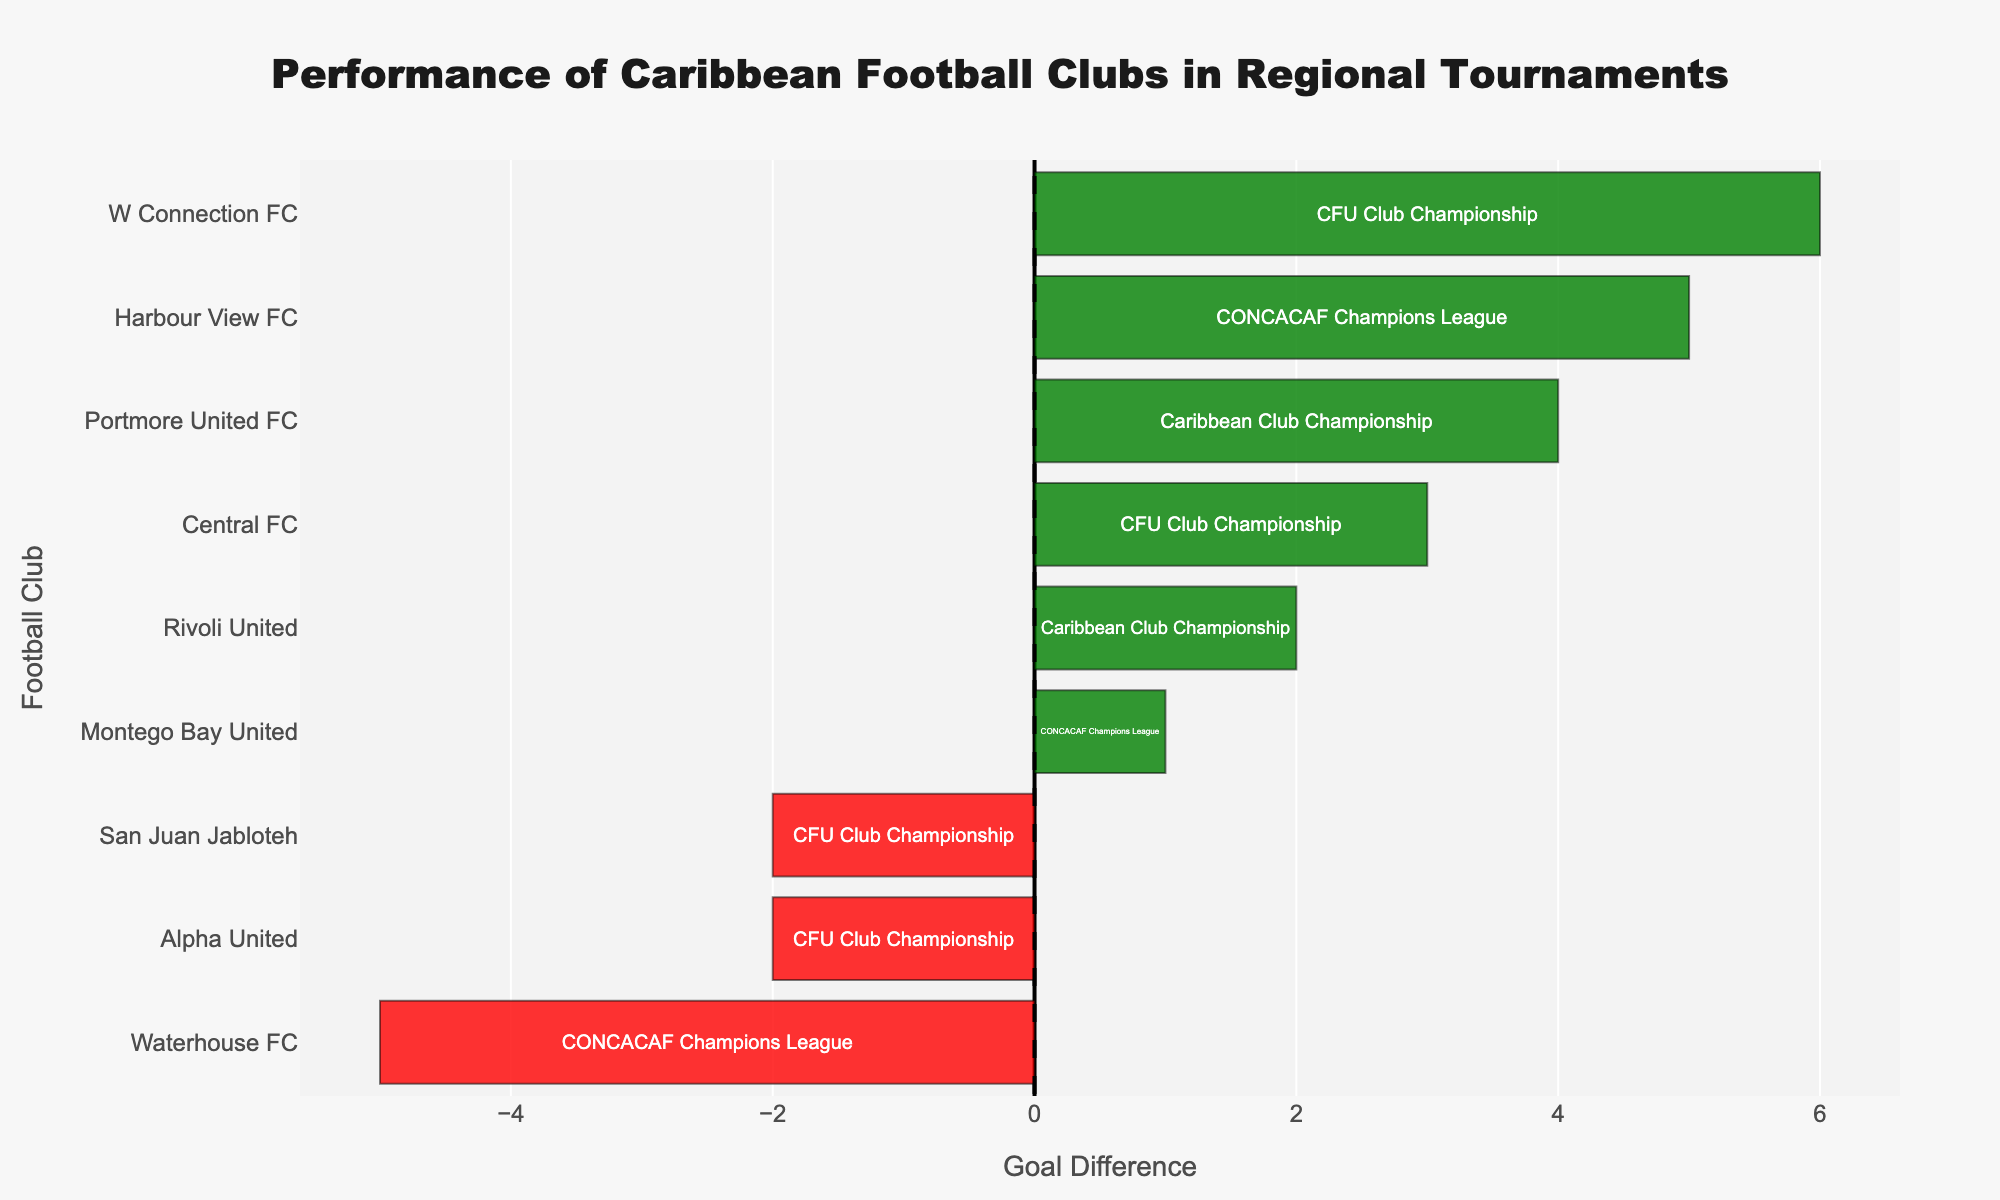Who has the highest positive goal difference? The figure shows the positive goal differences for the clubs in green bars. The club with the highest green bar has the highest positive goal difference, which is W Connection FC with a positive goal difference of 6.
Answer: W Connection FC Which club has the largest negative goal difference? The red bars represent the negative goal differences. The club with the longest red bar has the largest negative goal difference. Waterhouse FC has the longest red bar with a negative goal difference of 5.
Answer: Waterhouse FC How many clubs have a positive goal difference? Count the number of green bars in the chart. There are six clubs with green bars: Harbour View FC, Portmore United FC, W Connection FC, Central FC, Rivoli United, and Montego Bay United.
Answer: Six What is the combined goal difference of Harbour View FC and Montego Bay United? Harbour View FC has a goal difference of 5 and Montego Bay United has 1 (2 positive - 1 negative). Summing these gives 5 + 1 = 6.
Answer: 6 Among the clubs in the Caribbean Club Championship, which one has the lowest goal difference? Filter the clubs participating in the Caribbean Club Championship and compare their bars. Rivoli United has the lowest goal difference among them, which is 2.
Answer: Rivoli United Which club has an equal number of positive and negative goal differences? Look for any club with balanced bars, meaning the green and red bars are of equal length. No club has perfectly equal-length bars, implying no club has balanced positive and negative goal differences.
Answer: None Which club has a higher total goal difference, Alpha United or San Juan Jabloteh? Calculate the total goal difference. Alpha United has a goal difference of 1 - 3 = -2, and San Juan Jabloteh has -2. Both have equal total goal differences of -2.
Answer: Equal What is the median goal difference among all clubs? Organize the total goal differences: -5, -2, -2, 1, 2, 3, 4, 5, 6. The median value is the middle one when sorted, which is 2.
Answer: 2 